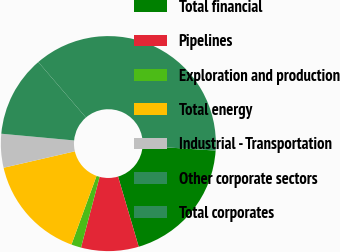Convert chart to OTSL. <chart><loc_0><loc_0><loc_500><loc_500><pie_chart><fcel>Total financial<fcel>Pipelines<fcel>Exploration and production<fcel>Total energy<fcel>Industrial - Transportation<fcel>Other corporate sectors<fcel>Total corporates<nl><fcel>19.41%<fcel>8.65%<fcel>1.48%<fcel>15.82%<fcel>5.07%<fcel>12.24%<fcel>37.33%<nl></chart> 